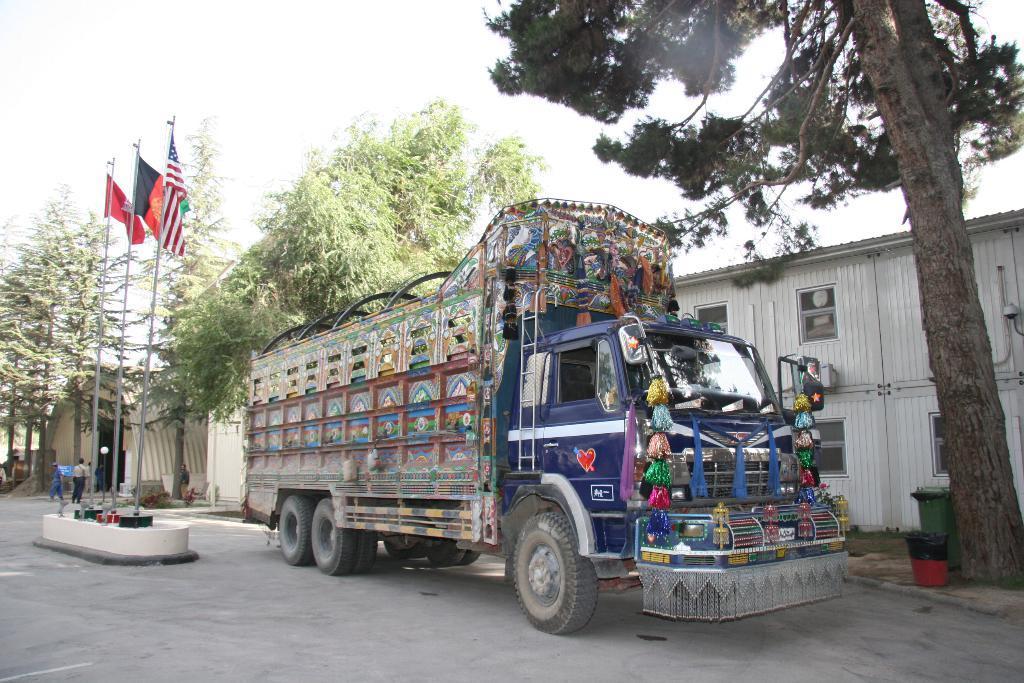Could you give a brief overview of what you see in this image? In this picture we can see blue truck on the road. Behind we can see white warehouse and some trees. In the middle of the road we can see some flags. On the top we can see the sky. 